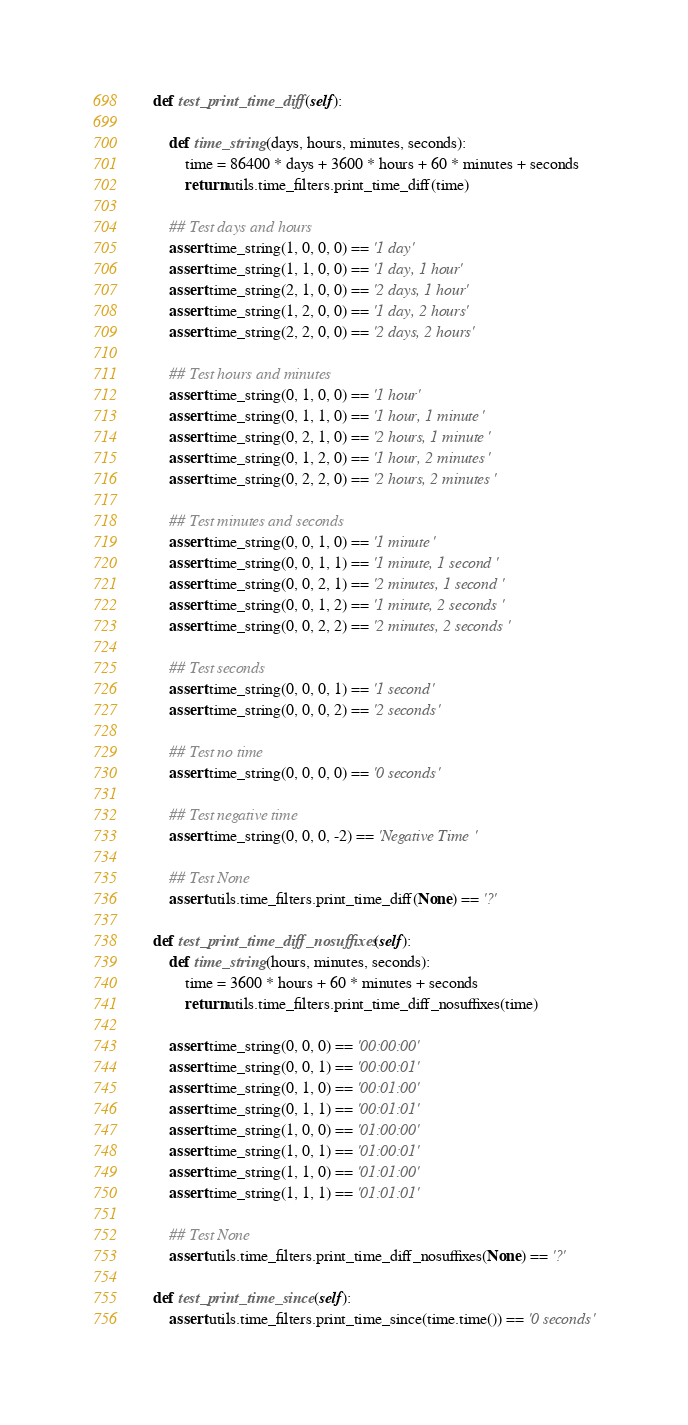<code> <loc_0><loc_0><loc_500><loc_500><_Python_>
    def test_print_time_diff(self):

        def time_string(days, hours, minutes, seconds):
            time = 86400 * days + 3600 * hours + 60 * minutes + seconds
            return utils.time_filters.print_time_diff(time)

        ## Test days and hours
        assert time_string(1, 0, 0, 0) == '1 day'
        assert time_string(1, 1, 0, 0) == '1 day, 1 hour'
        assert time_string(2, 1, 0, 0) == '2 days, 1 hour'
        assert time_string(1, 2, 0, 0) == '1 day, 2 hours'
        assert time_string(2, 2, 0, 0) == '2 days, 2 hours'

        ## Test hours and minutes
        assert time_string(0, 1, 0, 0) == '1 hour'
        assert time_string(0, 1, 1, 0) == '1 hour, 1 minute'
        assert time_string(0, 2, 1, 0) == '2 hours, 1 minute'
        assert time_string(0, 1, 2, 0) == '1 hour, 2 minutes'
        assert time_string(0, 2, 2, 0) == '2 hours, 2 minutes'

        ## Test minutes and seconds
        assert time_string(0, 0, 1, 0) == '1 minute'
        assert time_string(0, 0, 1, 1) == '1 minute, 1 second'
        assert time_string(0, 0, 2, 1) == '2 minutes, 1 second'
        assert time_string(0, 0, 1, 2) == '1 minute, 2 seconds'
        assert time_string(0, 0, 2, 2) == '2 minutes, 2 seconds'

        ## Test seconds
        assert time_string(0, 0, 0, 1) == '1 second'
        assert time_string(0, 0, 0, 2) == '2 seconds'

        ## Test no time
        assert time_string(0, 0, 0, 0) == '0 seconds'

        ## Test negative time
        assert time_string(0, 0, 0, -2) == 'Negative Time'

        ## Test None
        assert utils.time_filters.print_time_diff(None) == '?'

    def test_print_time_diff_nosuffixes(self):
        def time_string(hours, minutes, seconds):
            time = 3600 * hours + 60 * minutes + seconds
            return utils.time_filters.print_time_diff_nosuffixes(time)

        assert time_string(0, 0, 0) == '00:00:00'
        assert time_string(0, 0, 1) == '00:00:01'
        assert time_string(0, 1, 0) == '00:01:00'
        assert time_string(0, 1, 1) == '00:01:01'
        assert time_string(1, 0, 0) == '01:00:00'
        assert time_string(1, 0, 1) == '01:00:01'
        assert time_string(1, 1, 0) == '01:01:00'
        assert time_string(1, 1, 1) == '01:01:01'

        ## Test None
        assert utils.time_filters.print_time_diff_nosuffixes(None) == '?'

    def test_print_time_since(self):
        assert utils.time_filters.print_time_since(time.time()) == '0 seconds'
</code> 